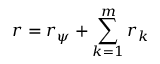Convert formula to latex. <formula><loc_0><loc_0><loc_500><loc_500>r = r _ { \psi } + \sum _ { k = 1 } ^ { m } r _ { k }</formula> 